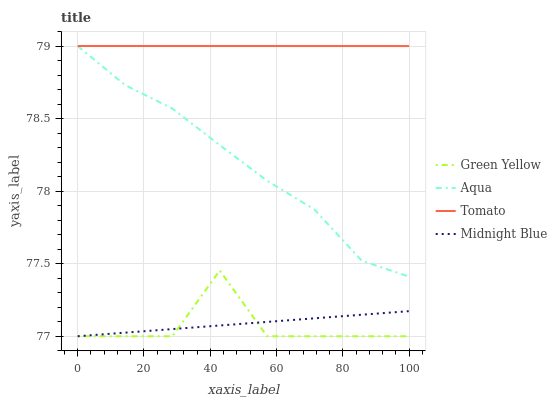Does Green Yellow have the minimum area under the curve?
Answer yes or no. Yes. Does Tomato have the maximum area under the curve?
Answer yes or no. Yes. Does Aqua have the minimum area under the curve?
Answer yes or no. No. Does Aqua have the maximum area under the curve?
Answer yes or no. No. Is Tomato the smoothest?
Answer yes or no. Yes. Is Green Yellow the roughest?
Answer yes or no. Yes. Is Aqua the smoothest?
Answer yes or no. No. Is Aqua the roughest?
Answer yes or no. No. Does Green Yellow have the lowest value?
Answer yes or no. Yes. Does Aqua have the lowest value?
Answer yes or no. No. Does Aqua have the highest value?
Answer yes or no. Yes. Does Green Yellow have the highest value?
Answer yes or no. No. Is Green Yellow less than Tomato?
Answer yes or no. Yes. Is Aqua greater than Midnight Blue?
Answer yes or no. Yes. Does Tomato intersect Aqua?
Answer yes or no. Yes. Is Tomato less than Aqua?
Answer yes or no. No. Is Tomato greater than Aqua?
Answer yes or no. No. Does Green Yellow intersect Tomato?
Answer yes or no. No. 